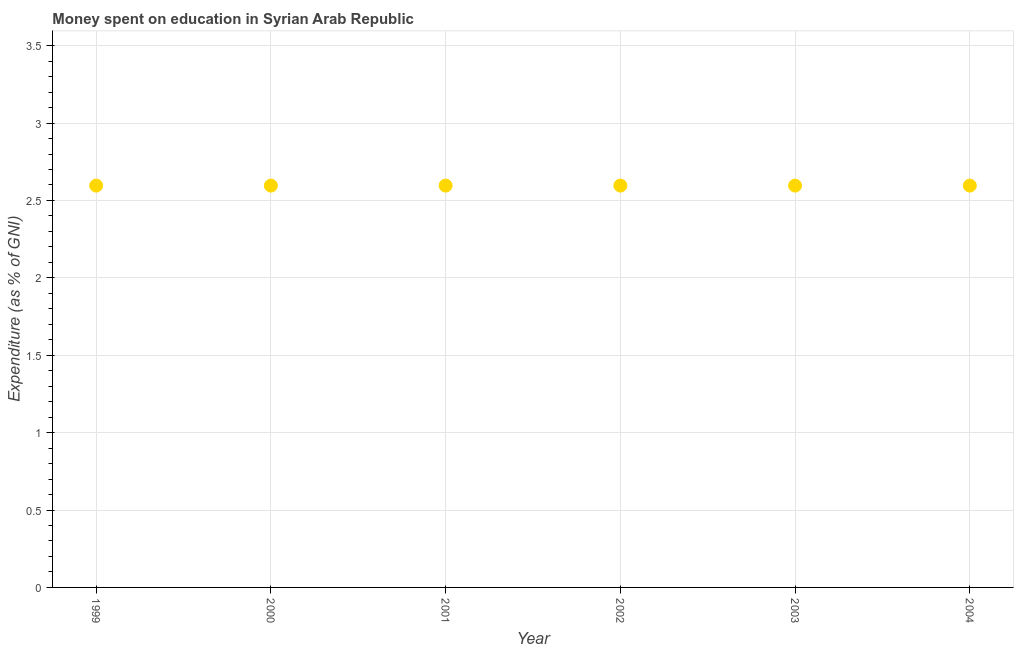What is the expenditure on education in 2001?
Make the answer very short. 2.6. Across all years, what is the maximum expenditure on education?
Your answer should be compact. 2.6. Across all years, what is the minimum expenditure on education?
Provide a short and direct response. 2.6. In which year was the expenditure on education maximum?
Offer a terse response. 1999. In which year was the expenditure on education minimum?
Your answer should be compact. 1999. What is the sum of the expenditure on education?
Offer a terse response. 15.58. What is the difference between the expenditure on education in 1999 and 2000?
Your answer should be compact. 0. What is the average expenditure on education per year?
Ensure brevity in your answer.  2.6. What is the median expenditure on education?
Your response must be concise. 2.6. In how many years, is the expenditure on education greater than 1.8 %?
Ensure brevity in your answer.  6. Do a majority of the years between 2003 and 2002 (inclusive) have expenditure on education greater than 2.2 %?
Offer a terse response. No. Is the difference between the expenditure on education in 2002 and 2003 greater than the difference between any two years?
Offer a very short reply. Yes. Is the sum of the expenditure on education in 2000 and 2003 greater than the maximum expenditure on education across all years?
Your answer should be very brief. Yes. Are the values on the major ticks of Y-axis written in scientific E-notation?
Offer a very short reply. No. Does the graph contain any zero values?
Your answer should be very brief. No. Does the graph contain grids?
Ensure brevity in your answer.  Yes. What is the title of the graph?
Your answer should be compact. Money spent on education in Syrian Arab Republic. What is the label or title of the X-axis?
Provide a short and direct response. Year. What is the label or title of the Y-axis?
Provide a succinct answer. Expenditure (as % of GNI). What is the Expenditure (as % of GNI) in 1999?
Provide a short and direct response. 2.6. What is the Expenditure (as % of GNI) in 2000?
Keep it short and to the point. 2.6. What is the Expenditure (as % of GNI) in 2001?
Your answer should be compact. 2.6. What is the Expenditure (as % of GNI) in 2002?
Ensure brevity in your answer.  2.6. What is the Expenditure (as % of GNI) in 2003?
Provide a succinct answer. 2.6. What is the Expenditure (as % of GNI) in 2004?
Offer a very short reply. 2.6. What is the difference between the Expenditure (as % of GNI) in 1999 and 2001?
Provide a short and direct response. 0. What is the difference between the Expenditure (as % of GNI) in 1999 and 2003?
Give a very brief answer. 0. What is the difference between the Expenditure (as % of GNI) in 2000 and 2001?
Ensure brevity in your answer.  0. What is the difference between the Expenditure (as % of GNI) in 2000 and 2002?
Ensure brevity in your answer.  0. What is the difference between the Expenditure (as % of GNI) in 2001 and 2002?
Keep it short and to the point. 0. What is the difference between the Expenditure (as % of GNI) in 2001 and 2003?
Offer a terse response. 0. What is the difference between the Expenditure (as % of GNI) in 2001 and 2004?
Keep it short and to the point. 0. What is the difference between the Expenditure (as % of GNI) in 2002 and 2003?
Your answer should be very brief. 0. What is the difference between the Expenditure (as % of GNI) in 2002 and 2004?
Your answer should be very brief. 0. What is the ratio of the Expenditure (as % of GNI) in 1999 to that in 2003?
Your response must be concise. 1. What is the ratio of the Expenditure (as % of GNI) in 2001 to that in 2004?
Your response must be concise. 1. 